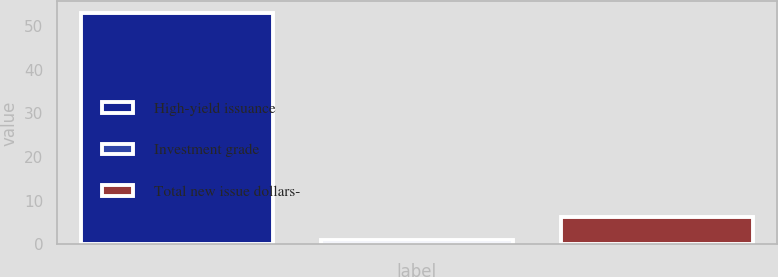Convert chart. <chart><loc_0><loc_0><loc_500><loc_500><bar_chart><fcel>High-yield issuance<fcel>Investment grade<fcel>Total new issue dollars-<nl><fcel>53<fcel>1<fcel>6.2<nl></chart> 